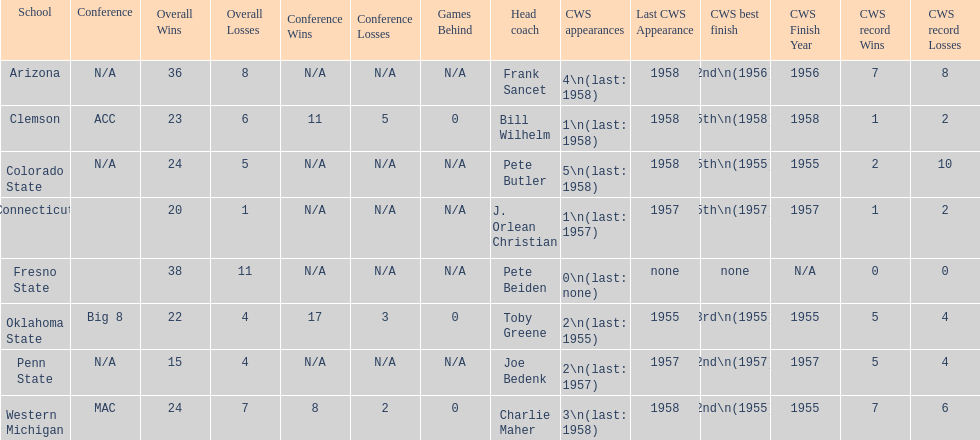List the schools that came in last place in the cws best finish. Clemson, Colorado State, Connecticut. 